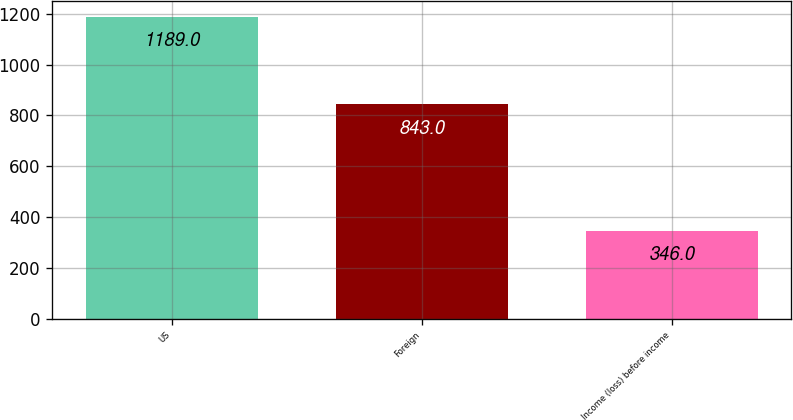Convert chart to OTSL. <chart><loc_0><loc_0><loc_500><loc_500><bar_chart><fcel>US<fcel>Foreign<fcel>Income (loss) before income<nl><fcel>1189<fcel>843<fcel>346<nl></chart> 